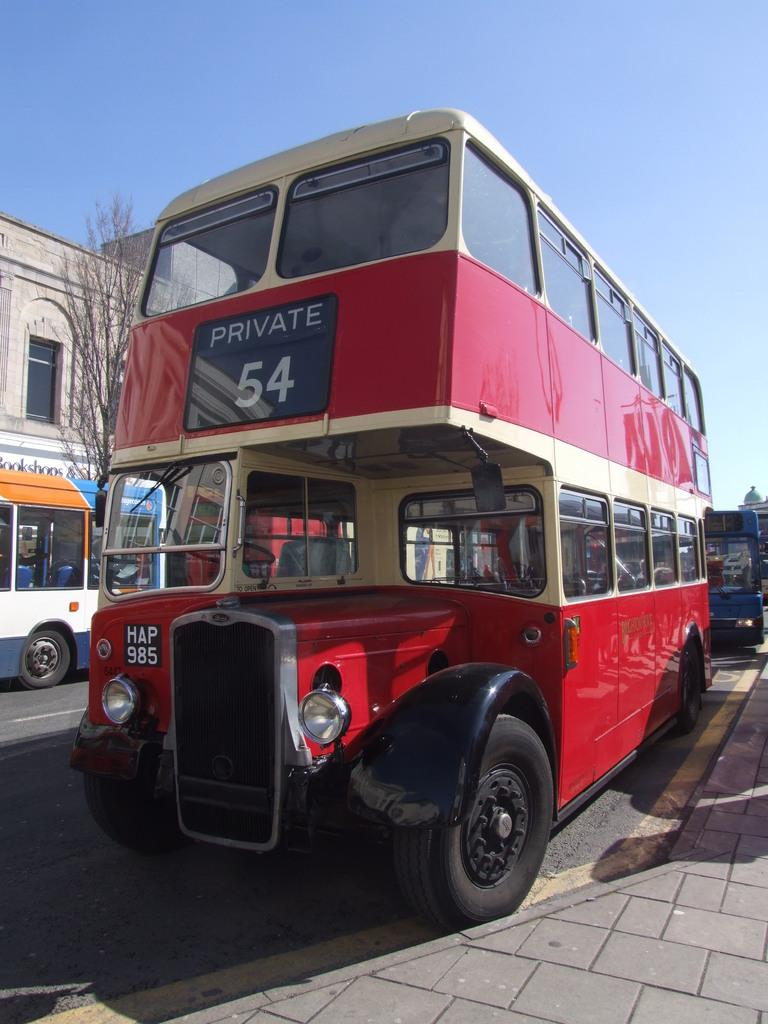What is on the road in the image? There is a vehicle on the road in the image. What can be seen to the left of the vehicle? There is a plant and a building to the left of the vehicle. What color is the sky in the background of the image? The blue sky is visible in the background of the image. How many feet of bait are hanging from the plant in the image? There is no bait or feet present in the image; it features a vehicle on the road, a plant, a building, and a blue sky in the background. 